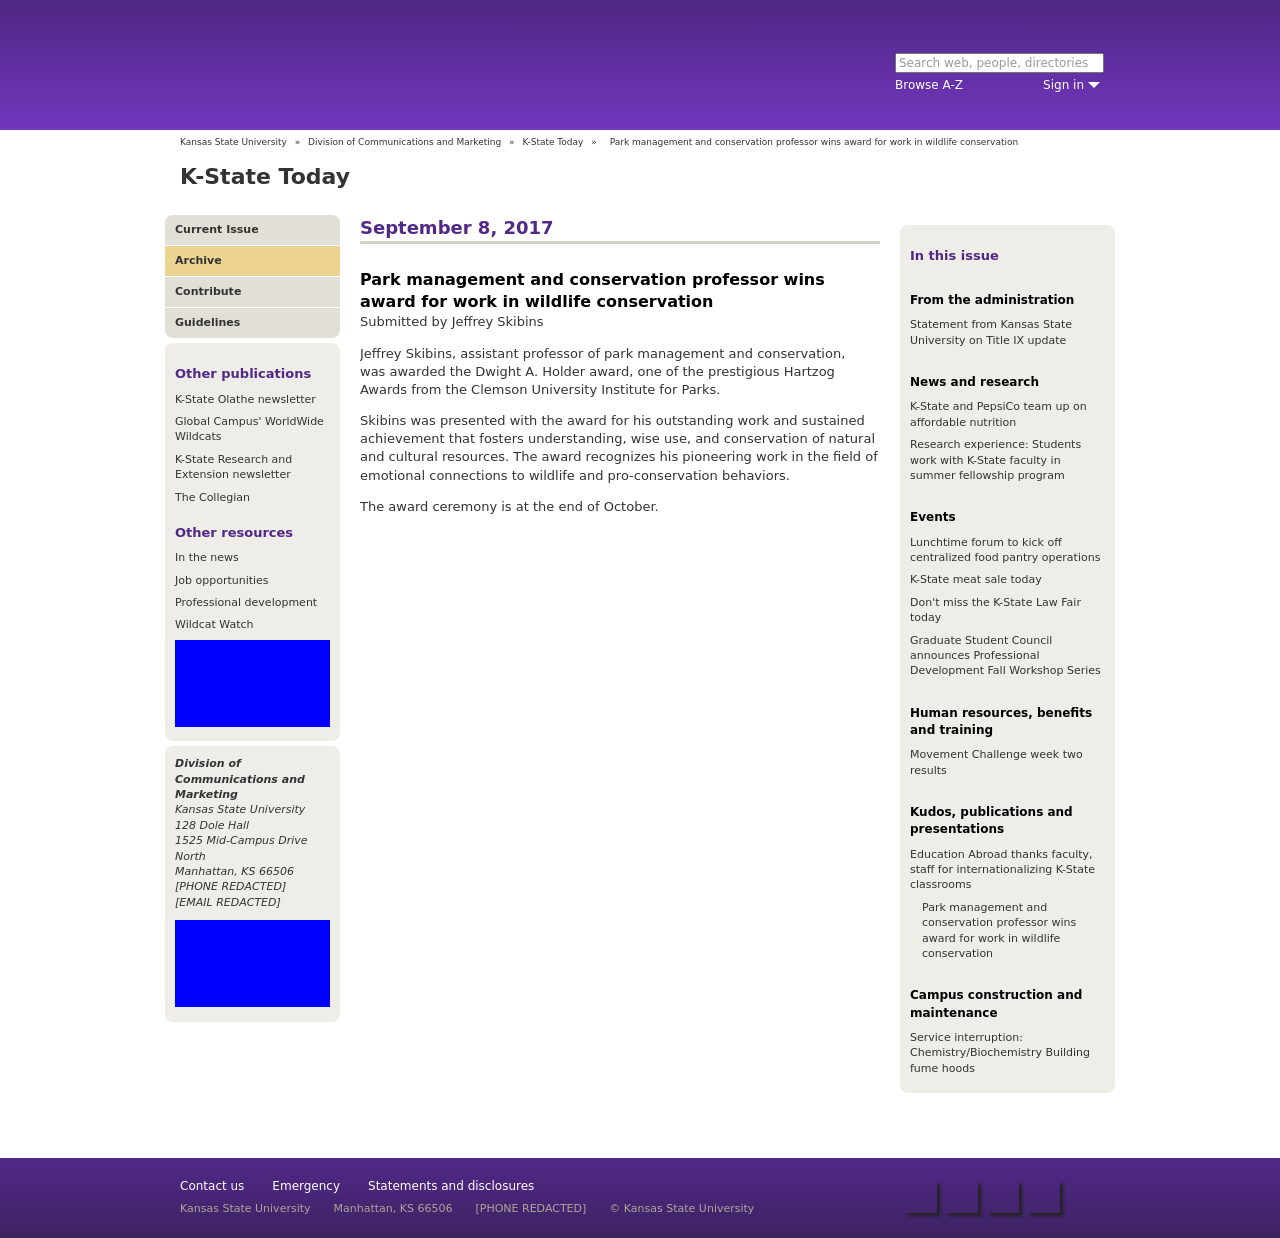Can you tell more about the nature of the research or contributions made by the professor that led to receiving the award? The professor, Jeffrey Skibins, conducted research on understanding, using, and conserving natural and cultural resources within park management. His work specifically involved understanding the emotional ties that people have with wildlife, which is fundamental in promoting pro-conservation behaviors and policies. His pioneering efforts in this area have substantially contributed to the field, warranting his recognition with the award. 